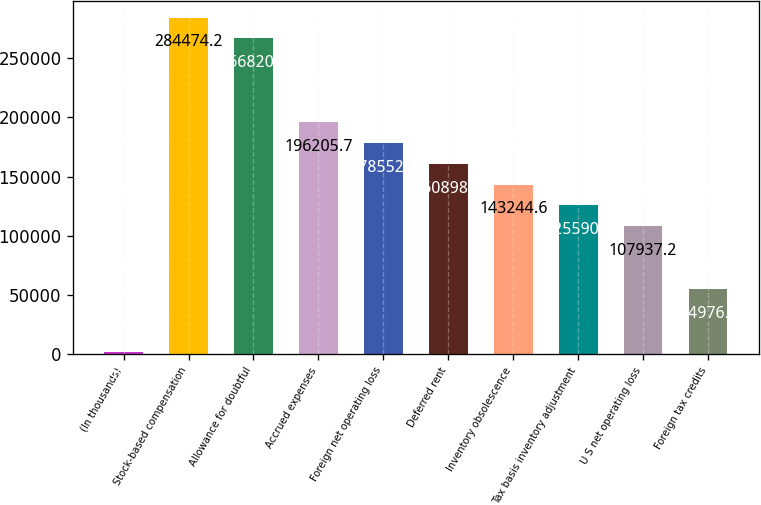Convert chart to OTSL. <chart><loc_0><loc_0><loc_500><loc_500><bar_chart><fcel>(In thousands)<fcel>Stock-based compensation<fcel>Allowance for doubtful<fcel>Accrued expenses<fcel>Foreign net operating loss<fcel>Deferred rent<fcel>Inventory obsolescence<fcel>Tax basis inventory adjustment<fcel>U S net operating loss<fcel>Foreign tax credits<nl><fcel>2015<fcel>284474<fcel>266820<fcel>196206<fcel>178552<fcel>160898<fcel>143245<fcel>125591<fcel>107937<fcel>54976.1<nl></chart> 